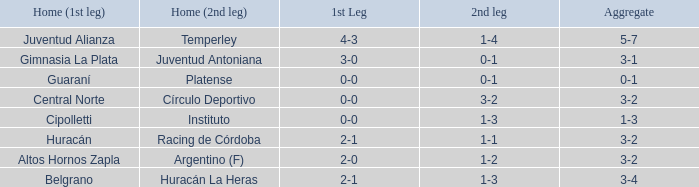Which team played their first leg at home with an aggregate score of 3-4? Belgrano. 